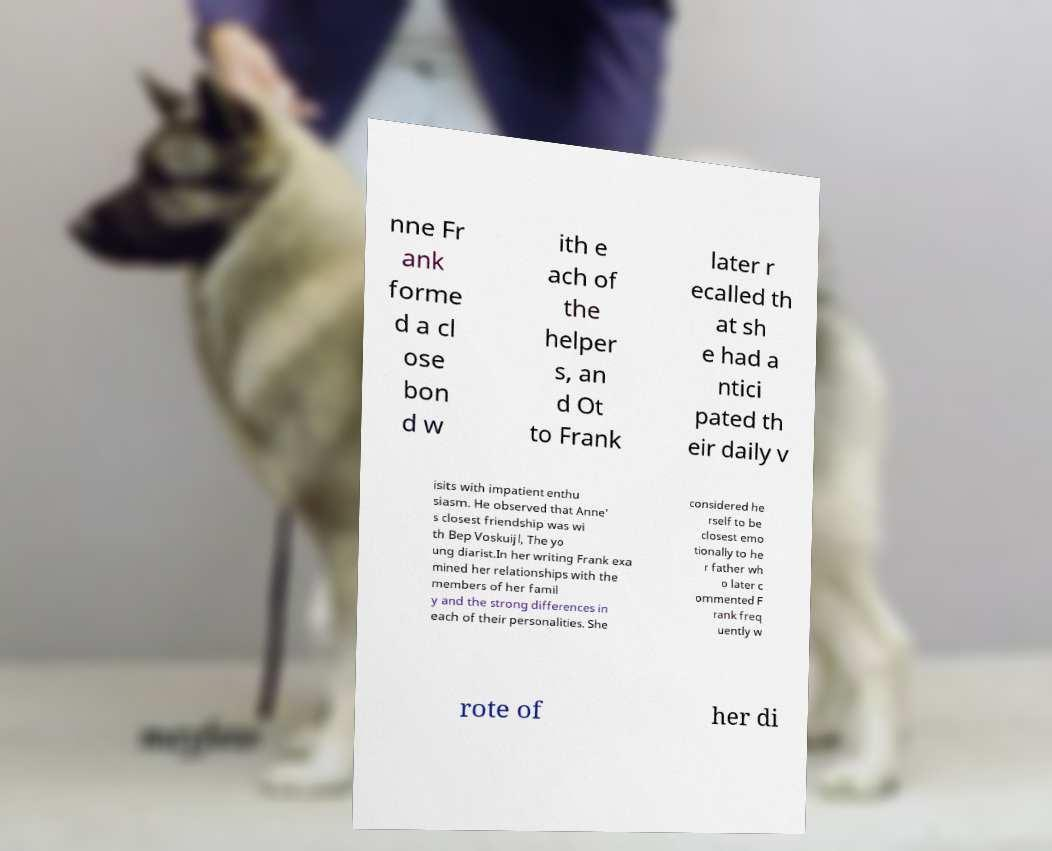I need the written content from this picture converted into text. Can you do that? nne Fr ank forme d a cl ose bon d w ith e ach of the helper s, an d Ot to Frank later r ecalled th at sh e had a ntici pated th eir daily v isits with impatient enthu siasm. He observed that Anne' s closest friendship was wi th Bep Voskuijl, The yo ung diarist.In her writing Frank exa mined her relationships with the members of her famil y and the strong differences in each of their personalities. She considered he rself to be closest emo tionally to he r father wh o later c ommented F rank freq uently w rote of her di 